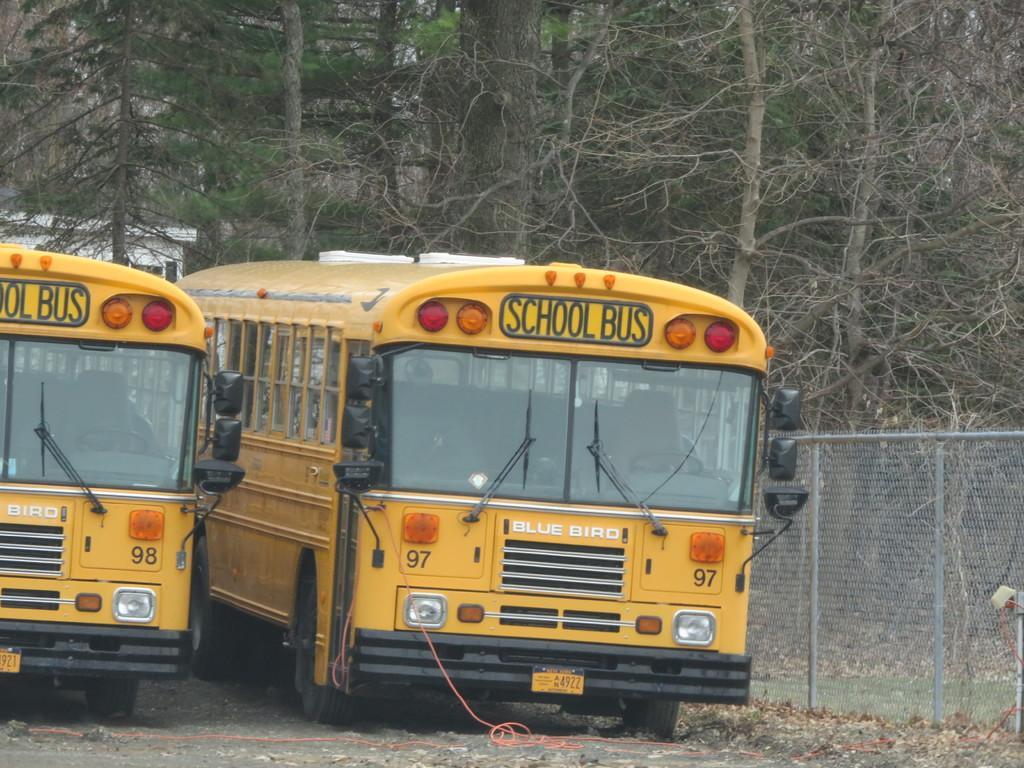Describe this image in one or two sentences. In the background we can see trees. Here we can see school buses in yellow color. At the right side of the picture we can see fence. 